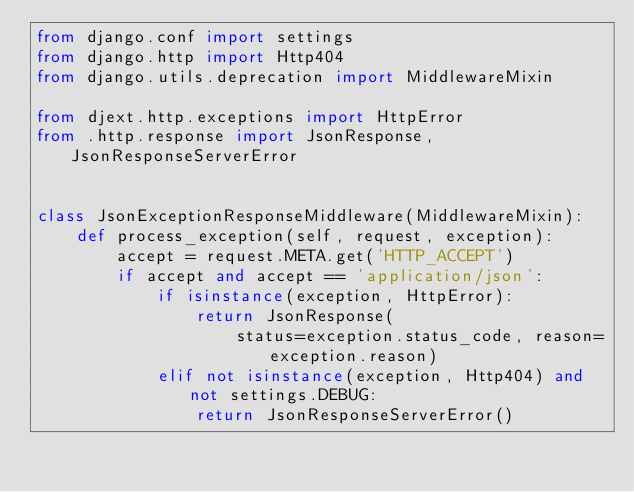Convert code to text. <code><loc_0><loc_0><loc_500><loc_500><_Python_>from django.conf import settings
from django.http import Http404
from django.utils.deprecation import MiddlewareMixin

from djext.http.exceptions import HttpError
from .http.response import JsonResponse, JsonResponseServerError


class JsonExceptionResponseMiddleware(MiddlewareMixin):
    def process_exception(self, request, exception):
        accept = request.META.get('HTTP_ACCEPT')
        if accept and accept == 'application/json':
            if isinstance(exception, HttpError):
                return JsonResponse(
                    status=exception.status_code, reason=exception.reason)
            elif not isinstance(exception, Http404) and not settings.DEBUG:
                return JsonResponseServerError()
</code> 